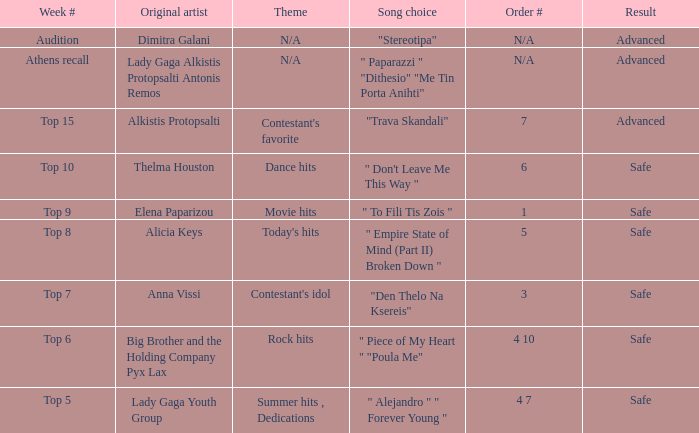Which artists have order # 1? Elena Paparizou. 